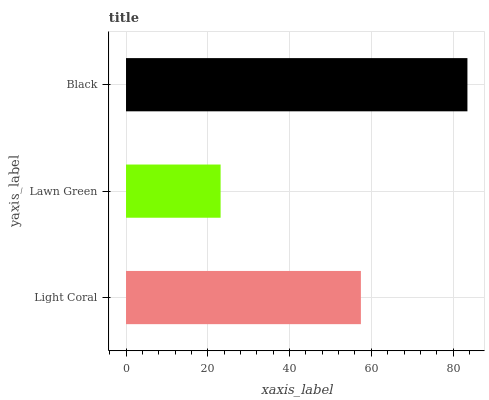Is Lawn Green the minimum?
Answer yes or no. Yes. Is Black the maximum?
Answer yes or no. Yes. Is Black the minimum?
Answer yes or no. No. Is Lawn Green the maximum?
Answer yes or no. No. Is Black greater than Lawn Green?
Answer yes or no. Yes. Is Lawn Green less than Black?
Answer yes or no. Yes. Is Lawn Green greater than Black?
Answer yes or no. No. Is Black less than Lawn Green?
Answer yes or no. No. Is Light Coral the high median?
Answer yes or no. Yes. Is Light Coral the low median?
Answer yes or no. Yes. Is Lawn Green the high median?
Answer yes or no. No. Is Lawn Green the low median?
Answer yes or no. No. 